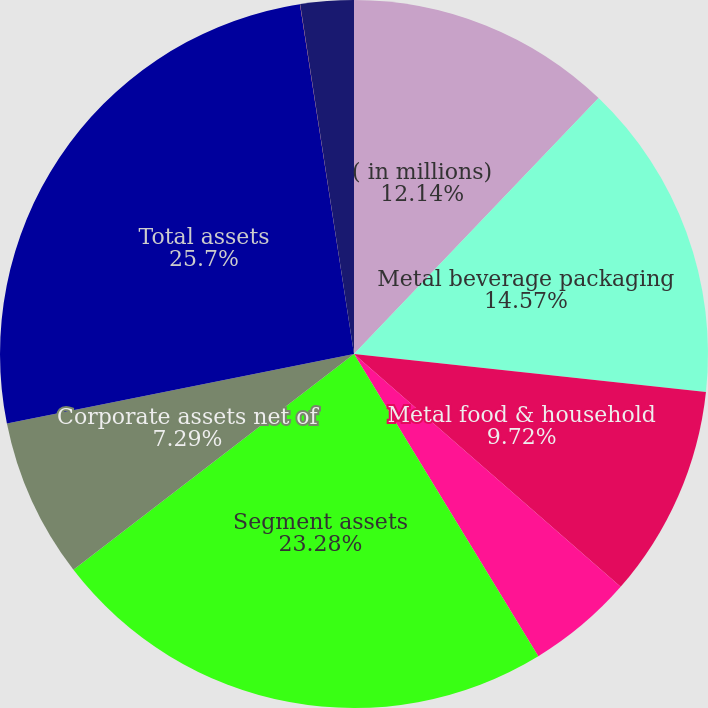Convert chart to OTSL. <chart><loc_0><loc_0><loc_500><loc_500><pie_chart><fcel>( in millions)<fcel>Metal beverage packaging<fcel>Metal food & household<fcel>Aerospace & technologies<fcel>Segment assets<fcel>Corporate assets net of<fcel>Total assets<fcel>Corporate<fcel>Investments in affiliates<nl><fcel>12.14%<fcel>14.57%<fcel>9.72%<fcel>4.86%<fcel>23.28%<fcel>7.29%<fcel>25.71%<fcel>0.01%<fcel>2.43%<nl></chart> 